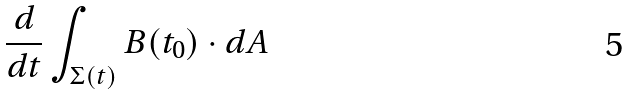<formula> <loc_0><loc_0><loc_500><loc_500>\frac { d } { d t } \int _ { \Sigma ( t ) } B ( t _ { 0 } ) \cdot d A</formula> 